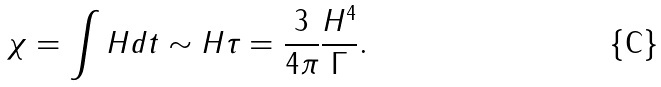<formula> <loc_0><loc_0><loc_500><loc_500>\chi = \int H d t \sim H \tau = \frac { 3 } { 4 \pi } \frac { H ^ { 4 } } { \Gamma } .</formula> 